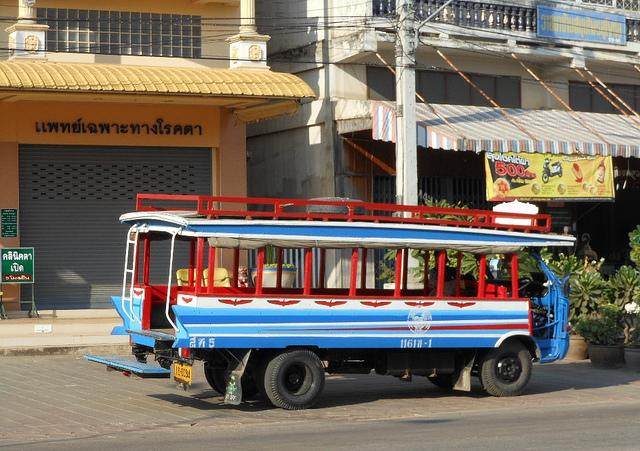The color scheme of this vehicle represents what flag? Please explain your reasoning. france. The vehicle has a blue, white, and red color scheme. the flags for mexico and djibouti have green on them, and the flag for kazakhstan does not have red. 